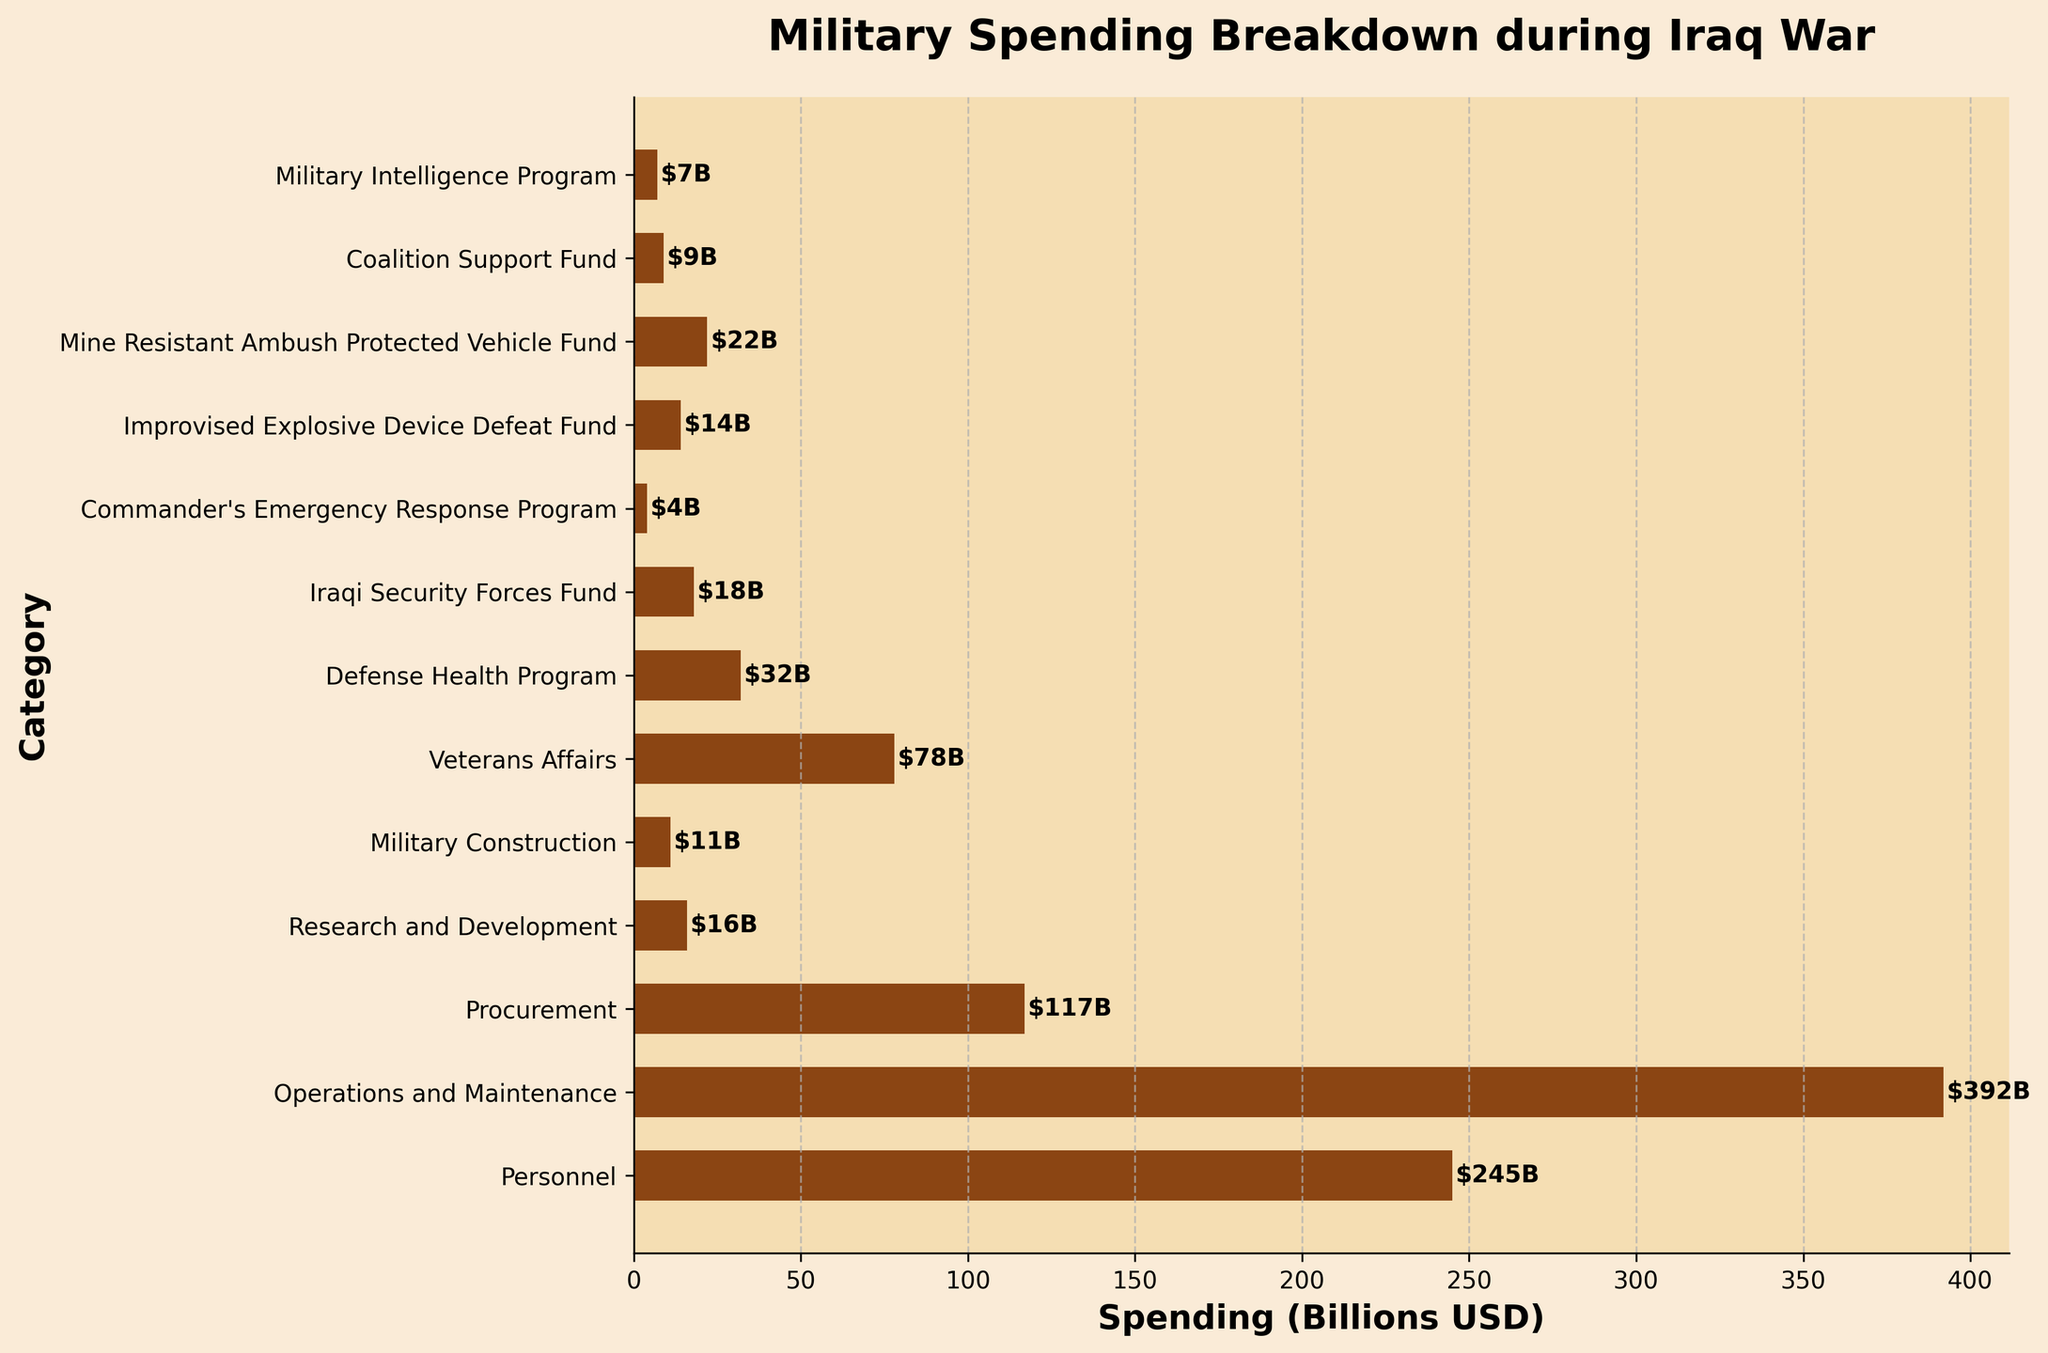Which category has the highest military spending? The category with the highest spending will have the longest bar. "Operations and Maintenance" has the longest bar, indicating the highest spending.
Answer: Operations and Maintenance Which category has the least military spending? The category with the shortest bar represents the least spending. The "Commander's Emergency Response Program" has the shortest bar.
Answer: Commander's Emergency Response Program What is the total spending on Military Construction and Veterans Affairs? To find the total, sum the spending of both categories: Military Construction ($11B) + Veterans Affairs ($78B).
Answer: $89B How much more was spent on Operations and Maintenance than on Procurement? Subtract the spending on Procurement from the spending on Operations and Maintenance: $392B - $117B.
Answer: $275B Of Personnel, Defense Health Program, and Coalition Support Fund, which had the highest spending? Compare the lengths of the bars for these three categories. "Personnel" has the longest bar among them.
Answer: Personnel What is the combined spending for Research and Development, Military Intelligence Program, and Coalition Support Fund? To find the total, sum the spending of all three categories: Research and Development ($16B) + Military Intelligence Program ($7B) + Coalition Support Fund ($9B).
Answer: $32B Is the spending on Veterans Affairs greater than that on the Iraqi Security Forces Fund? Compare the lengths of the bars for these two categories. Veterans Affairs ($78B) is greater than the Iraqi Security Forces Fund ($18B).
Answer: Yes What is the difference between the highest and lowest categories in terms of spending? The highest is Operations and Maintenance ($392B), and the lowest is Commander's Emergency Response Program ($4B). The difference is $392B - $4B.
Answer: $388B What fraction of the total spending does Procurement represent? Total all categories: $245B + $392B + $117B + $16B + $11B + $78B + $32B + $18B + $4B + $14B + $22B + $9B + $7B = $965B. Then, $\frac{117}{965}$ can be calculated.
Answer: About 0.121 Which categories have spending above $100 billion? The bars labeled "Operations and Maintenance" ($392B) and "Personnel" ($245B) are the only ones above $100B.
Answer: Operations and Maintenance, Personnel 